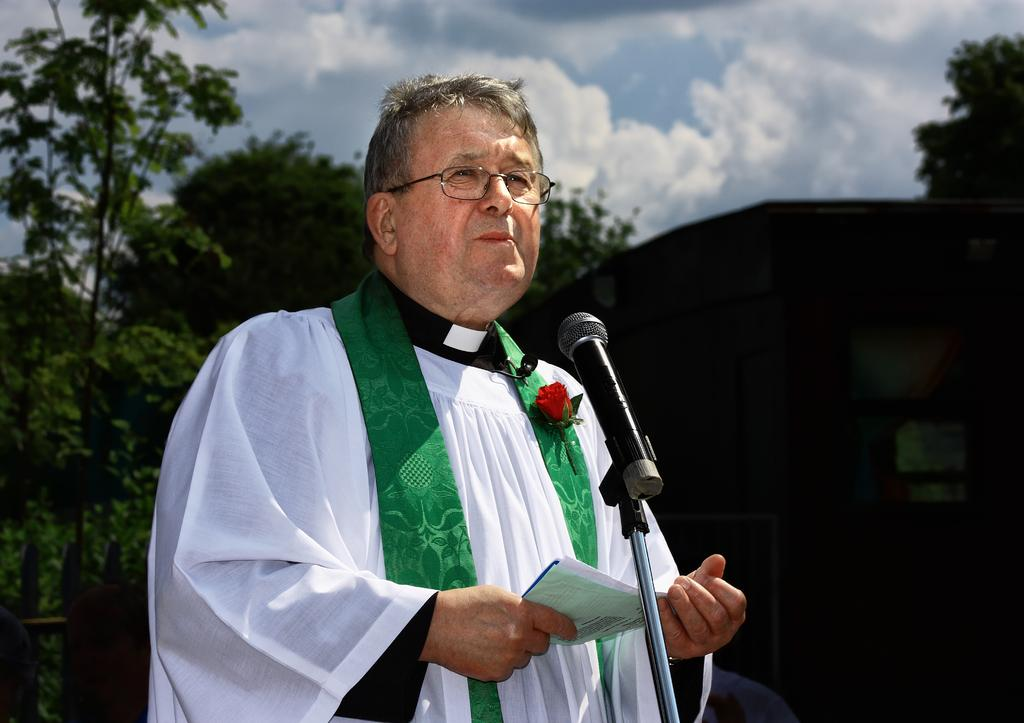What is the main subject of the image? There is a man standing in the middle of the image. What is the man holding in the image? The man is holding some papers. What object is present that is typically used for amplifying sound? There is a microphone in the image. What type of vegetation can be seen behind the man? There are trees visible behind the man. What is visible at the top of the image? The sky is visible at the top of the image. What can be observed in the sky? There are clouds in the sky. What type of stamp can be seen on the man's forehead in the image? There is no stamp visible on the man's forehead in the image. What direction is the man looking in the image? The image does not provide information about the direction the man is looking. 